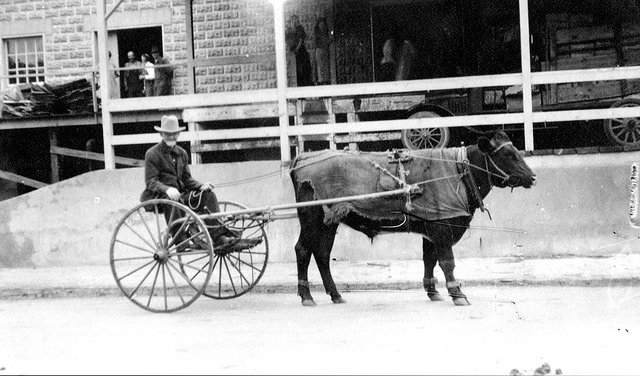<image>Who does the sign say to vote for? It is unknown who the sign says to vote for. It can be 'Hoover', 'President', 'Carver' or 'Kennedy'. There also seems to be no sign in the image. Who does the sign say to vote for? The sign doesn't indicate who to vote for. 